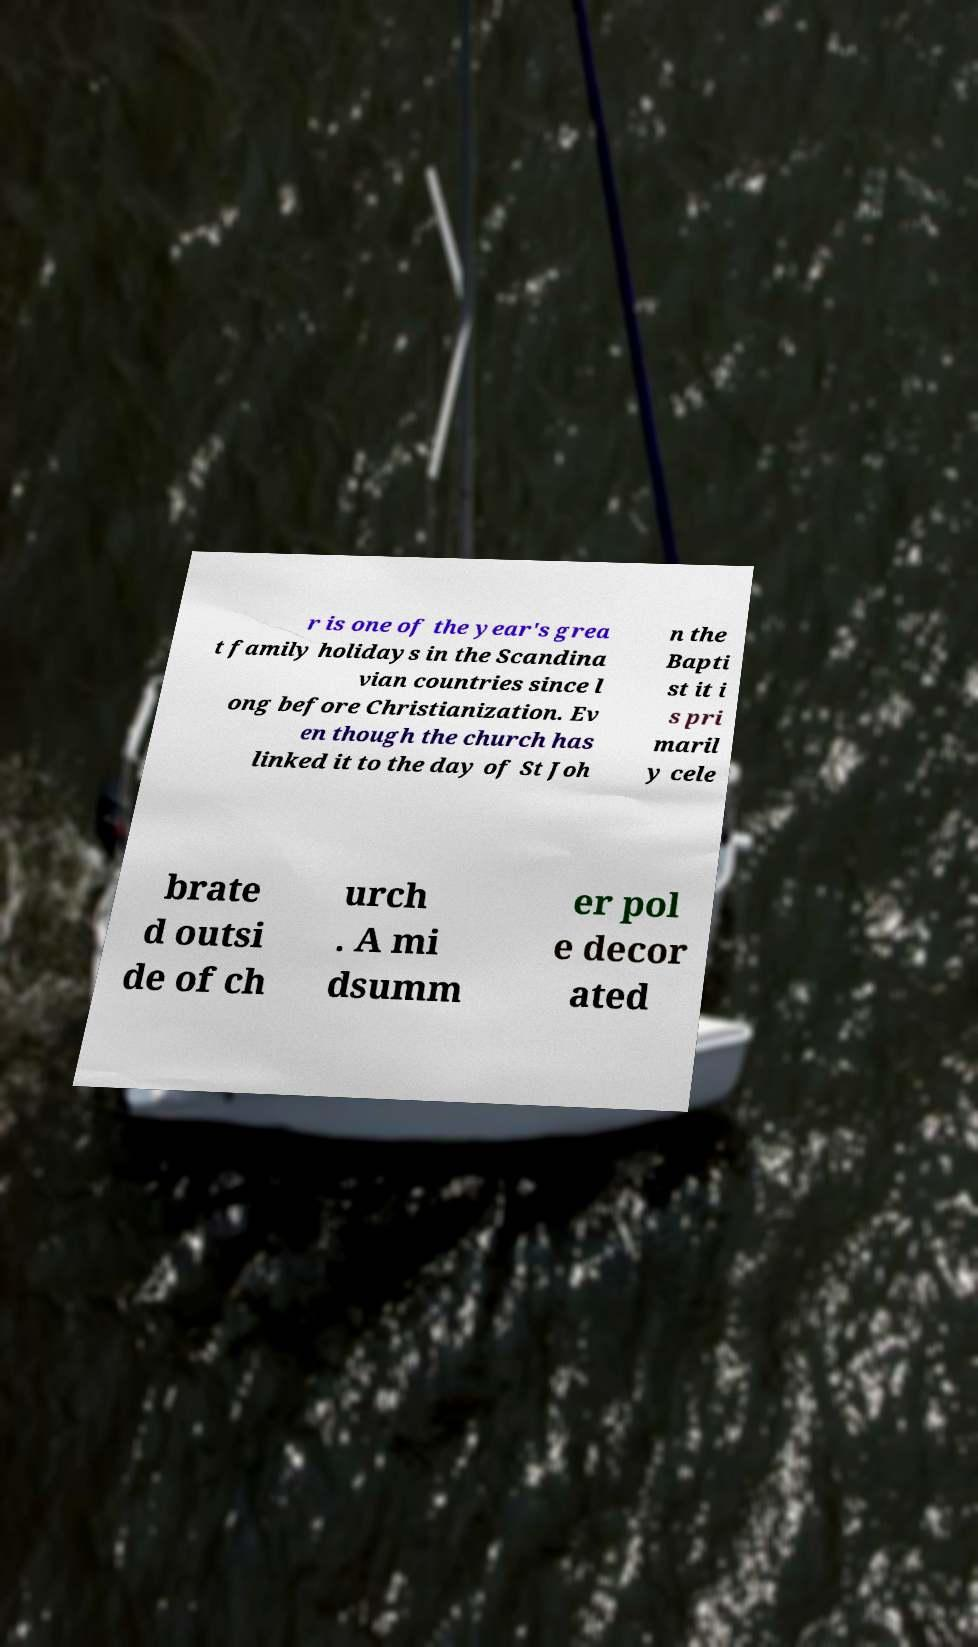Could you assist in decoding the text presented in this image and type it out clearly? r is one of the year's grea t family holidays in the Scandina vian countries since l ong before Christianization. Ev en though the church has linked it to the day of St Joh n the Bapti st it i s pri maril y cele brate d outsi de of ch urch . A mi dsumm er pol e decor ated 